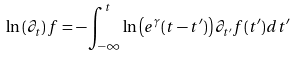<formula> <loc_0><loc_0><loc_500><loc_500>\ln \left ( \partial _ { t } \right ) f = - \int _ { - \infty } ^ { t } \ln \left ( e ^ { \gamma } ( t - t ^ { \prime } ) \right ) \partial _ { t ^ { \prime } } f ( t ^ { \prime } ) d t ^ { \prime }</formula> 